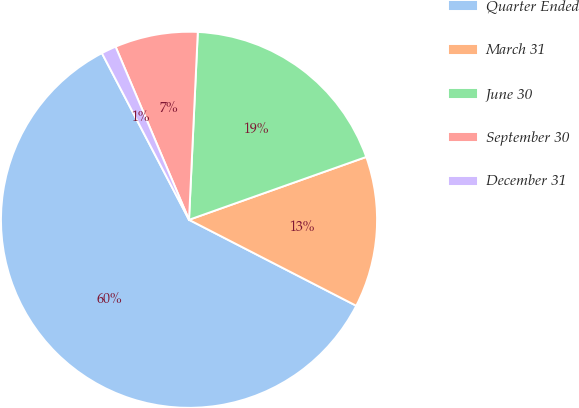<chart> <loc_0><loc_0><loc_500><loc_500><pie_chart><fcel>Quarter Ended<fcel>March 31<fcel>June 30<fcel>September 30<fcel>December 31<nl><fcel>59.77%<fcel>12.98%<fcel>18.83%<fcel>7.13%<fcel>1.28%<nl></chart> 